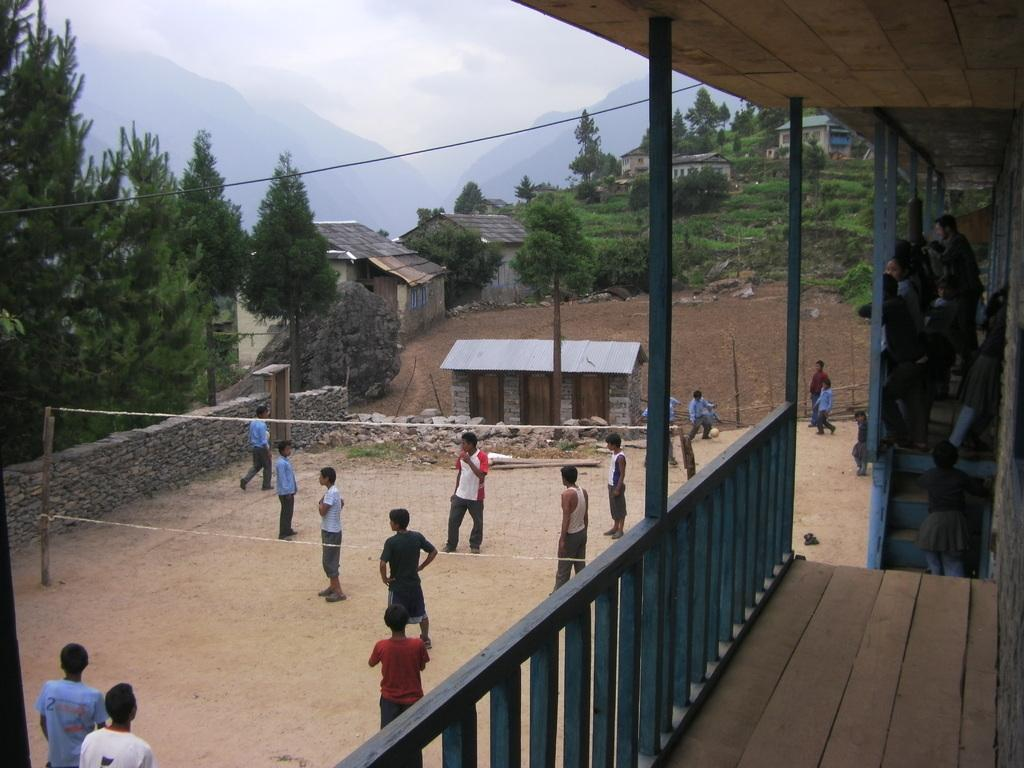What can be seen in the sky in the image? The sky with clouds is visible in the image. What type of natural features are present in the image? There are hills and trees in the image. What type of structures can be seen in the image? There are sheds and walls visible in the image. What are the people in the image doing? Persons are standing on the ground and on the stairs in the image. What type of equipment is present in the image? Grills are present in the image. What type of authority is present in the image? There is no authority figure present in the image. What type of tax can be seen being paid in the image? There is no tax being paid in the image. 